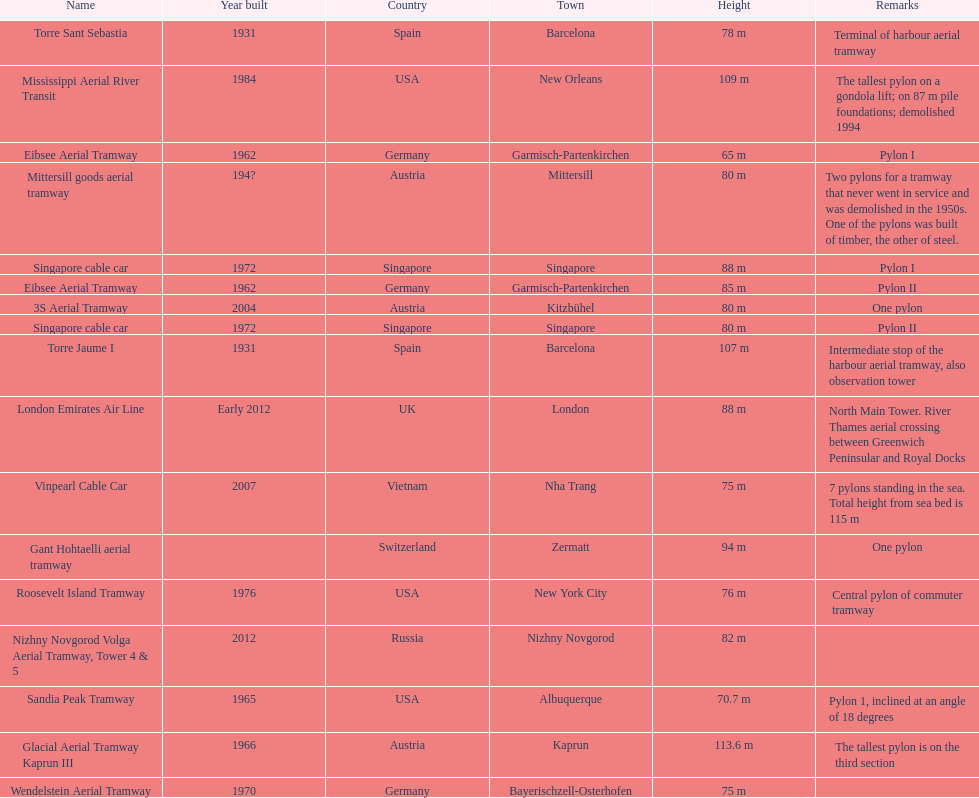What year was the last pylon in germany built? 1970. 